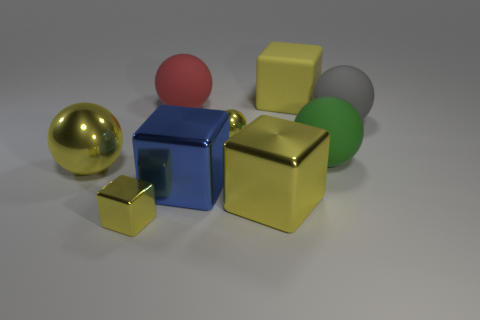What color is the rubber block that is the same size as the red object? yellow 